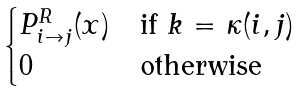<formula> <loc_0><loc_0><loc_500><loc_500>\begin{cases} P ^ { R } _ { i \to j } ( x ) & \text {if $k$ = $\kappa(i,j)$} \\ 0 & \text {otherwise} \end{cases}</formula> 